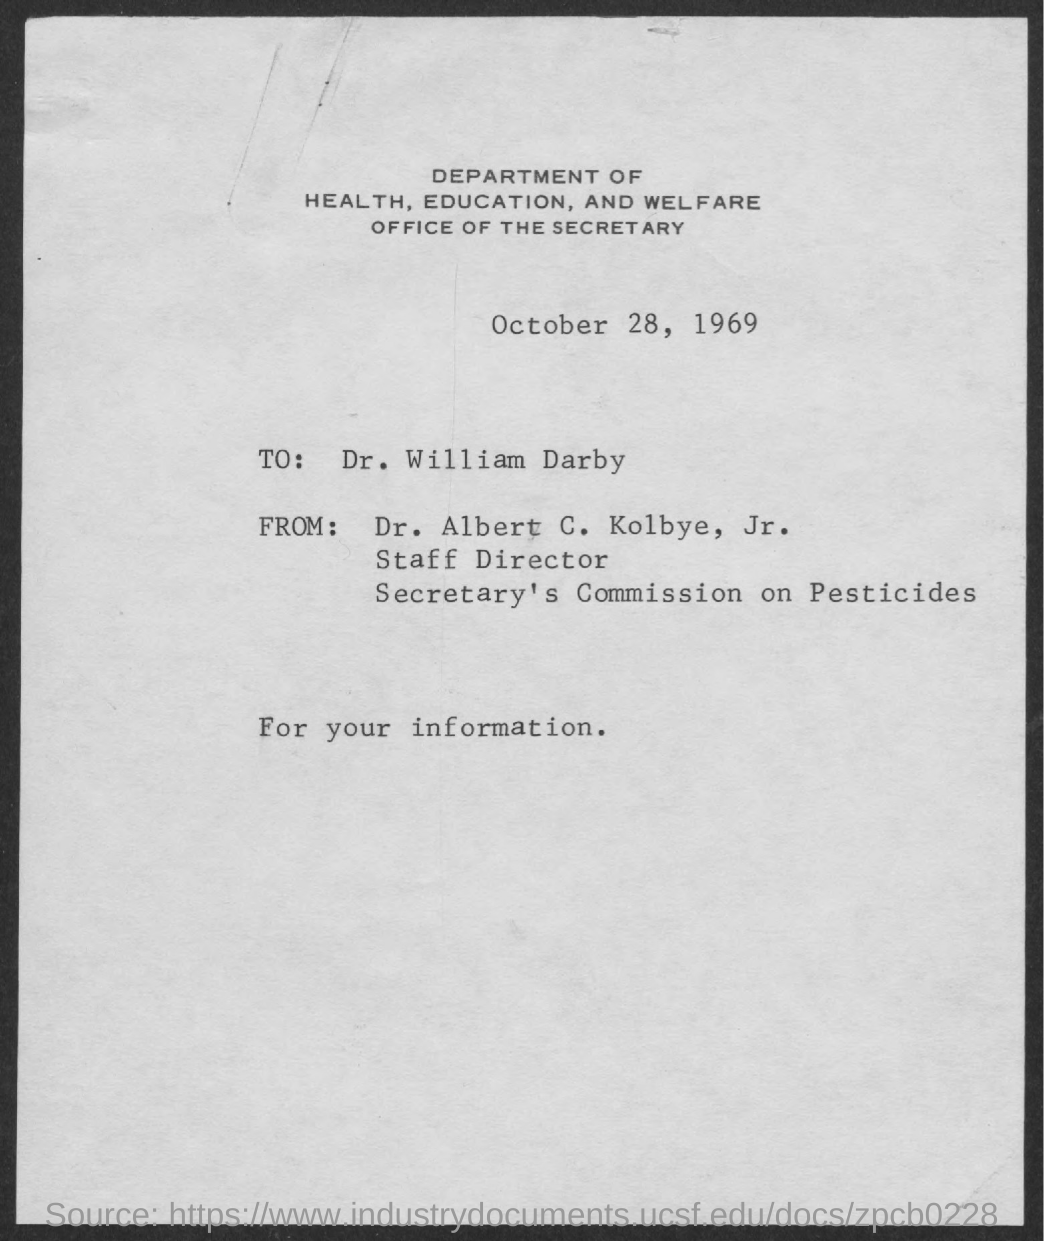List a handful of essential elements in this visual. The date mentioned in the document is October 28, 1969. The Staff Director of the Secretary's Commission on Pesticides is Dr. Albert C. Kolbye, Jr. The person to whom this letter is addressed is Dr. William Darby. 